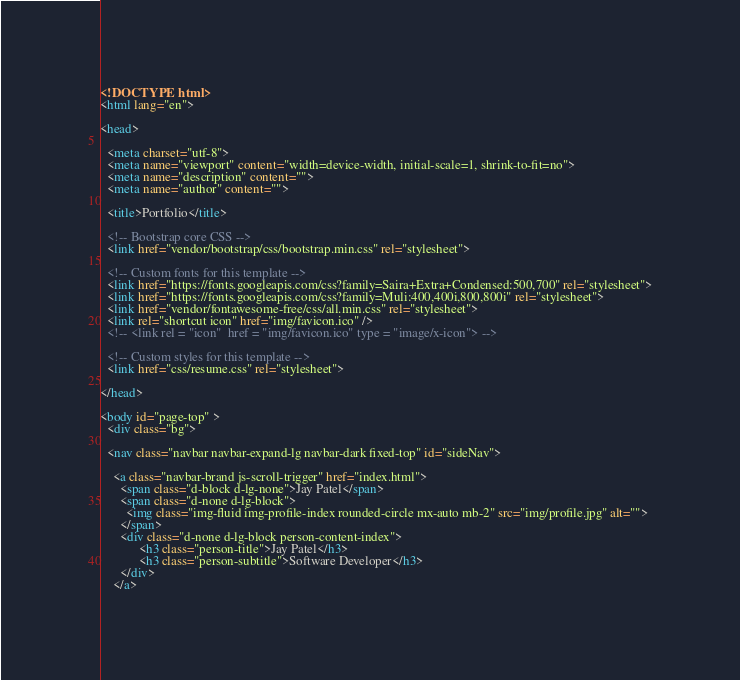<code> <loc_0><loc_0><loc_500><loc_500><_HTML_><!DOCTYPE html>
<html lang="en">

<head>
  
  <meta charset="utf-8">
  <meta name="viewport" content="width=device-width, initial-scale=1, shrink-to-fit=no">
  <meta name="description" content="">
  <meta name="author" content="">

  <title>Portfolio</title>

  <!-- Bootstrap core CSS -->
  <link href="vendor/bootstrap/css/bootstrap.min.css" rel="stylesheet">

  <!-- Custom fonts for this template -->
  <link href="https://fonts.googleapis.com/css?family=Saira+Extra+Condensed:500,700" rel="stylesheet">
  <link href="https://fonts.googleapis.com/css?family=Muli:400,400i,800,800i" rel="stylesheet">
  <link href="vendor/fontawesome-free/css/all.min.css" rel="stylesheet">
  <link rel="shortcut icon" href="img/favicon.ico" />
  <!-- <link rel = "icon"  href = "img/favicon.ico" type = "image/x-icon"> --> 

  <!-- Custom styles for this template -->
  <link href="css/resume.css" rel="stylesheet">

</head>

<body id="page-top" >   
  <div class="bg">

  <nav class="navbar navbar-expand-lg navbar-dark fixed-top" id="sideNav">
    
    <a class="navbar-brand js-scroll-trigger" href="index.html">
      <span class="d-block d-lg-none">Jay Patel</span>
      <span class="d-none d-lg-block">
        <img class="img-fluid img-profile-index rounded-circle mx-auto mb-2" src="img/profile.jpg" alt="">
      </span>
      <div class="d-none d-lg-block person-content-index">
            <h3 class="person-title">Jay Patel</h3>
            <h3 class="person-subtitle">Software Developer</h3>
      </div>
    </a></code> 